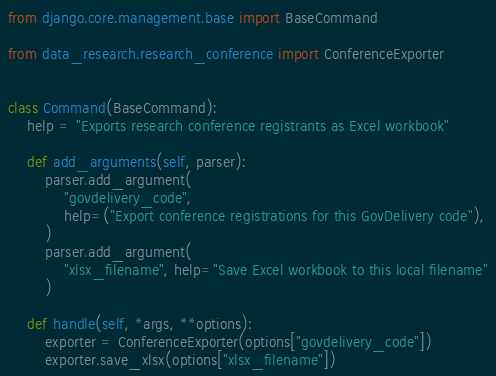Convert code to text. <code><loc_0><loc_0><loc_500><loc_500><_Python_>from django.core.management.base import BaseCommand

from data_research.research_conference import ConferenceExporter


class Command(BaseCommand):
    help = "Exports research conference registrants as Excel workbook"

    def add_arguments(self, parser):
        parser.add_argument(
            "govdelivery_code",
            help=("Export conference registrations for this GovDelivery code"),
        )
        parser.add_argument(
            "xlsx_filename", help="Save Excel workbook to this local filename"
        )

    def handle(self, *args, **options):
        exporter = ConferenceExporter(options["govdelivery_code"])
        exporter.save_xlsx(options["xlsx_filename"])
</code> 